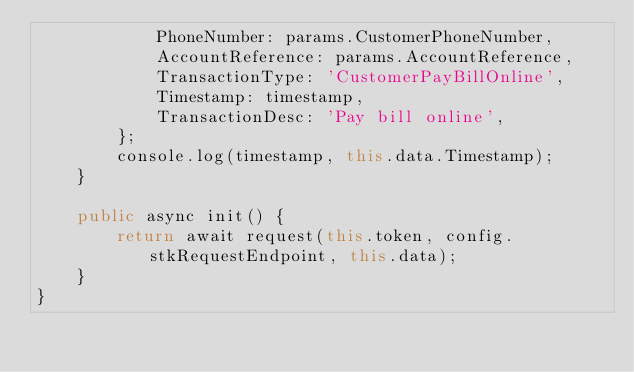<code> <loc_0><loc_0><loc_500><loc_500><_TypeScript_>            PhoneNumber: params.CustomerPhoneNumber,
            AccountReference: params.AccountReference,
            TransactionType: 'CustomerPayBillOnline',
            Timestamp: timestamp,
            TransactionDesc: 'Pay bill online',
        };
        console.log(timestamp, this.data.Timestamp);
    }

    public async init() {
        return await request(this.token, config.stkRequestEndpoint, this.data);
    }
}
</code> 